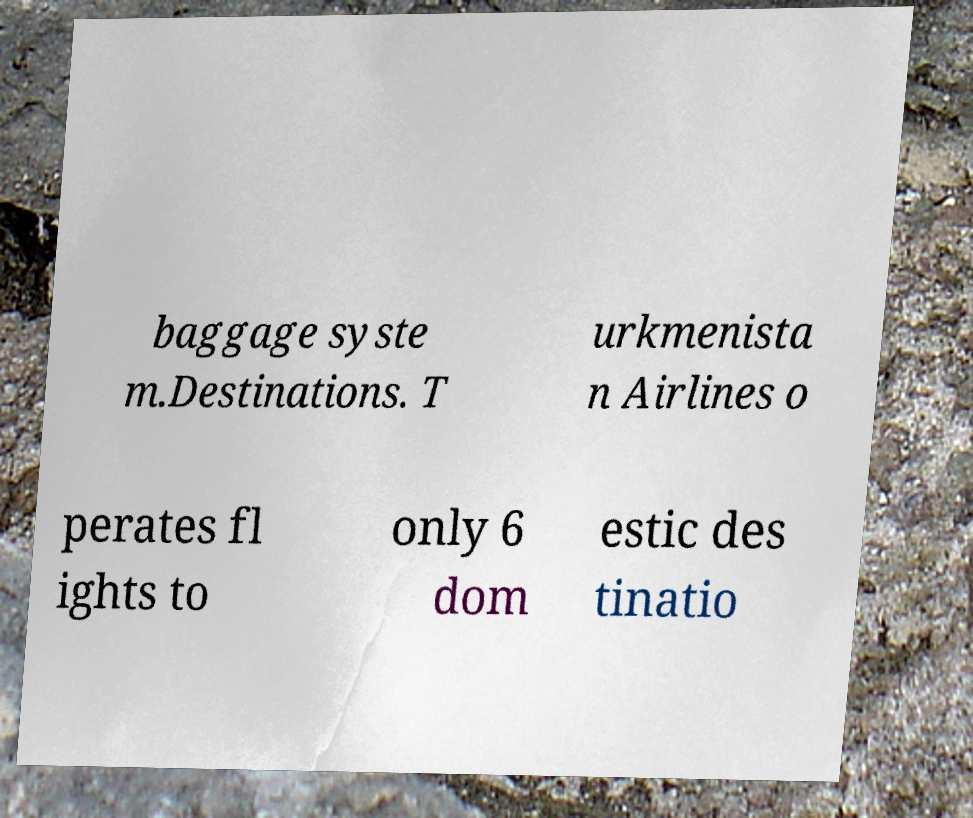Please read and relay the text visible in this image. What does it say? baggage syste m.Destinations. T urkmenista n Airlines o perates fl ights to only 6 dom estic des tinatio 